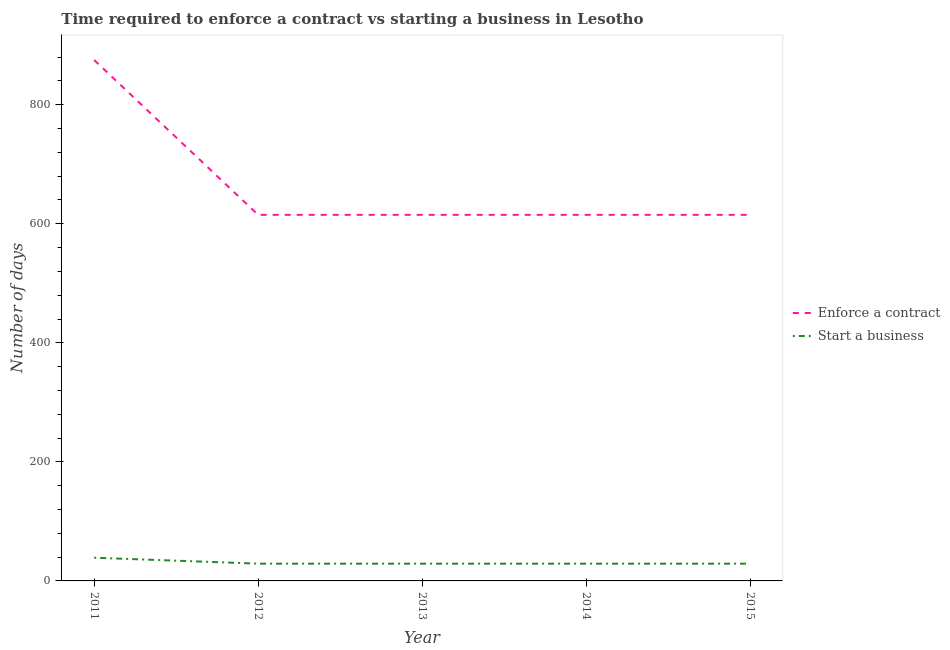How many different coloured lines are there?
Your answer should be very brief. 2. What is the number of days to start a business in 2015?
Provide a succinct answer. 29. Across all years, what is the maximum number of days to start a business?
Provide a short and direct response. 39. Across all years, what is the minimum number of days to start a business?
Make the answer very short. 29. In which year was the number of days to start a business maximum?
Your answer should be very brief. 2011. What is the total number of days to enforece a contract in the graph?
Your answer should be very brief. 3335. What is the difference between the number of days to start a business in 2011 and that in 2013?
Your answer should be compact. 10. What is the difference between the number of days to enforece a contract in 2012 and the number of days to start a business in 2014?
Keep it short and to the point. 586. What is the average number of days to start a business per year?
Ensure brevity in your answer.  31. In the year 2014, what is the difference between the number of days to start a business and number of days to enforece a contract?
Provide a succinct answer. -586. Is the number of days to start a business in 2012 less than that in 2015?
Ensure brevity in your answer.  No. What is the difference between the highest and the lowest number of days to start a business?
Offer a terse response. 10. In how many years, is the number of days to start a business greater than the average number of days to start a business taken over all years?
Provide a succinct answer. 1. Does the number of days to start a business monotonically increase over the years?
Provide a succinct answer. No. Is the number of days to enforece a contract strictly greater than the number of days to start a business over the years?
Make the answer very short. Yes. Is the number of days to enforece a contract strictly less than the number of days to start a business over the years?
Give a very brief answer. No. How many lines are there?
Your answer should be compact. 2. How many years are there in the graph?
Offer a very short reply. 5. What is the difference between two consecutive major ticks on the Y-axis?
Your answer should be very brief. 200. Does the graph contain grids?
Ensure brevity in your answer.  No. Where does the legend appear in the graph?
Keep it short and to the point. Center right. How many legend labels are there?
Keep it short and to the point. 2. What is the title of the graph?
Give a very brief answer. Time required to enforce a contract vs starting a business in Lesotho. What is the label or title of the X-axis?
Keep it short and to the point. Year. What is the label or title of the Y-axis?
Offer a very short reply. Number of days. What is the Number of days in Enforce a contract in 2011?
Make the answer very short. 875. What is the Number of days in Enforce a contract in 2012?
Offer a terse response. 615. What is the Number of days in Enforce a contract in 2013?
Make the answer very short. 615. What is the Number of days in Enforce a contract in 2014?
Give a very brief answer. 615. What is the Number of days in Start a business in 2014?
Offer a terse response. 29. What is the Number of days in Enforce a contract in 2015?
Offer a terse response. 615. What is the Number of days of Start a business in 2015?
Your answer should be very brief. 29. Across all years, what is the maximum Number of days of Enforce a contract?
Your answer should be very brief. 875. Across all years, what is the minimum Number of days in Enforce a contract?
Give a very brief answer. 615. What is the total Number of days of Enforce a contract in the graph?
Your response must be concise. 3335. What is the total Number of days of Start a business in the graph?
Offer a very short reply. 155. What is the difference between the Number of days in Enforce a contract in 2011 and that in 2012?
Your answer should be compact. 260. What is the difference between the Number of days in Start a business in 2011 and that in 2012?
Offer a very short reply. 10. What is the difference between the Number of days in Enforce a contract in 2011 and that in 2013?
Keep it short and to the point. 260. What is the difference between the Number of days in Start a business in 2011 and that in 2013?
Ensure brevity in your answer.  10. What is the difference between the Number of days in Enforce a contract in 2011 and that in 2014?
Your answer should be very brief. 260. What is the difference between the Number of days of Start a business in 2011 and that in 2014?
Your answer should be very brief. 10. What is the difference between the Number of days of Enforce a contract in 2011 and that in 2015?
Your response must be concise. 260. What is the difference between the Number of days in Start a business in 2011 and that in 2015?
Make the answer very short. 10. What is the difference between the Number of days of Enforce a contract in 2012 and that in 2013?
Provide a short and direct response. 0. What is the difference between the Number of days of Start a business in 2012 and that in 2013?
Offer a very short reply. 0. What is the difference between the Number of days in Enforce a contract in 2012 and that in 2014?
Offer a very short reply. 0. What is the difference between the Number of days in Start a business in 2012 and that in 2015?
Your answer should be very brief. 0. What is the difference between the Number of days of Start a business in 2013 and that in 2014?
Ensure brevity in your answer.  0. What is the difference between the Number of days in Enforce a contract in 2013 and that in 2015?
Provide a succinct answer. 0. What is the difference between the Number of days in Enforce a contract in 2014 and that in 2015?
Give a very brief answer. 0. What is the difference between the Number of days in Enforce a contract in 2011 and the Number of days in Start a business in 2012?
Offer a very short reply. 846. What is the difference between the Number of days of Enforce a contract in 2011 and the Number of days of Start a business in 2013?
Offer a very short reply. 846. What is the difference between the Number of days of Enforce a contract in 2011 and the Number of days of Start a business in 2014?
Offer a terse response. 846. What is the difference between the Number of days of Enforce a contract in 2011 and the Number of days of Start a business in 2015?
Offer a very short reply. 846. What is the difference between the Number of days of Enforce a contract in 2012 and the Number of days of Start a business in 2013?
Ensure brevity in your answer.  586. What is the difference between the Number of days in Enforce a contract in 2012 and the Number of days in Start a business in 2014?
Provide a short and direct response. 586. What is the difference between the Number of days in Enforce a contract in 2012 and the Number of days in Start a business in 2015?
Offer a very short reply. 586. What is the difference between the Number of days in Enforce a contract in 2013 and the Number of days in Start a business in 2014?
Your answer should be very brief. 586. What is the difference between the Number of days of Enforce a contract in 2013 and the Number of days of Start a business in 2015?
Offer a very short reply. 586. What is the difference between the Number of days in Enforce a contract in 2014 and the Number of days in Start a business in 2015?
Make the answer very short. 586. What is the average Number of days in Enforce a contract per year?
Your answer should be compact. 667. In the year 2011, what is the difference between the Number of days in Enforce a contract and Number of days in Start a business?
Ensure brevity in your answer.  836. In the year 2012, what is the difference between the Number of days in Enforce a contract and Number of days in Start a business?
Offer a terse response. 586. In the year 2013, what is the difference between the Number of days of Enforce a contract and Number of days of Start a business?
Ensure brevity in your answer.  586. In the year 2014, what is the difference between the Number of days of Enforce a contract and Number of days of Start a business?
Your answer should be very brief. 586. In the year 2015, what is the difference between the Number of days in Enforce a contract and Number of days in Start a business?
Offer a very short reply. 586. What is the ratio of the Number of days of Enforce a contract in 2011 to that in 2012?
Offer a very short reply. 1.42. What is the ratio of the Number of days of Start a business in 2011 to that in 2012?
Ensure brevity in your answer.  1.34. What is the ratio of the Number of days of Enforce a contract in 2011 to that in 2013?
Your answer should be very brief. 1.42. What is the ratio of the Number of days in Start a business in 2011 to that in 2013?
Give a very brief answer. 1.34. What is the ratio of the Number of days of Enforce a contract in 2011 to that in 2014?
Offer a terse response. 1.42. What is the ratio of the Number of days of Start a business in 2011 to that in 2014?
Your answer should be compact. 1.34. What is the ratio of the Number of days in Enforce a contract in 2011 to that in 2015?
Offer a terse response. 1.42. What is the ratio of the Number of days of Start a business in 2011 to that in 2015?
Ensure brevity in your answer.  1.34. What is the ratio of the Number of days in Enforce a contract in 2012 to that in 2013?
Offer a very short reply. 1. What is the ratio of the Number of days of Start a business in 2012 to that in 2013?
Make the answer very short. 1. What is the ratio of the Number of days of Enforce a contract in 2012 to that in 2014?
Make the answer very short. 1. What is the ratio of the Number of days in Enforce a contract in 2012 to that in 2015?
Give a very brief answer. 1. What is the ratio of the Number of days in Start a business in 2013 to that in 2014?
Provide a succinct answer. 1. What is the ratio of the Number of days in Enforce a contract in 2013 to that in 2015?
Offer a very short reply. 1. What is the ratio of the Number of days in Start a business in 2013 to that in 2015?
Your response must be concise. 1. What is the difference between the highest and the second highest Number of days in Enforce a contract?
Provide a succinct answer. 260. What is the difference between the highest and the lowest Number of days in Enforce a contract?
Your response must be concise. 260. What is the difference between the highest and the lowest Number of days in Start a business?
Provide a short and direct response. 10. 